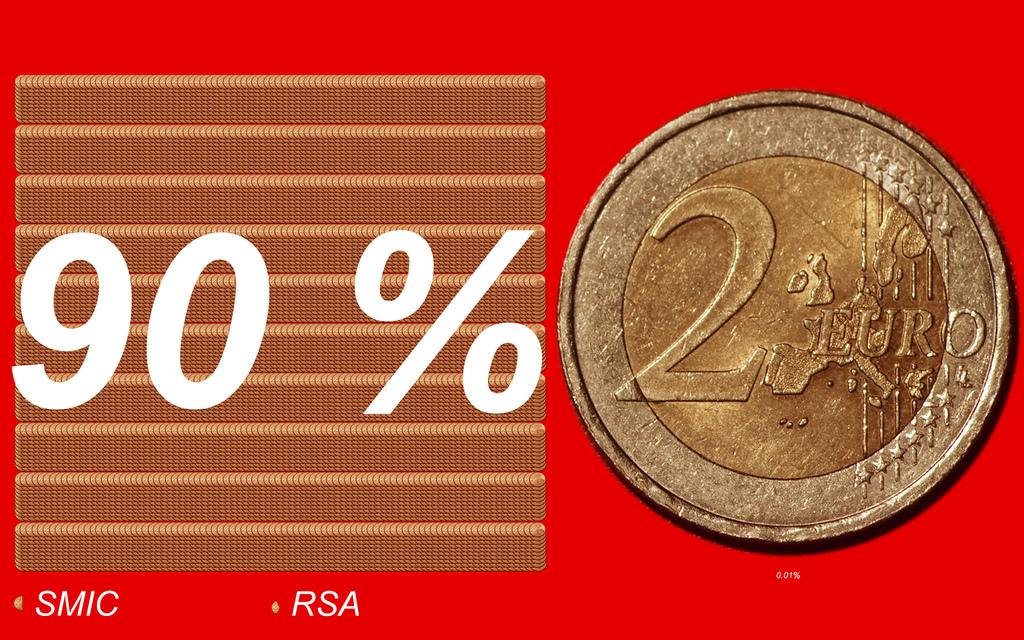How many euros is this coin worth?
Your answer should be very brief. 2. Is the number 2 on the left of the word euro?
Your answer should be compact. Yes. 